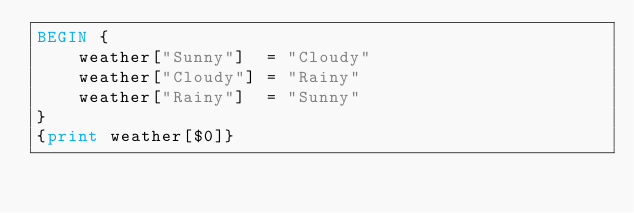<code> <loc_0><loc_0><loc_500><loc_500><_Awk_>BEGIN {
    weather["Sunny"]  = "Cloudy"
    weather["Cloudy"] = "Rainy"
    weather["Rainy"]  = "Sunny"
}
{print weather[$0]}
</code> 